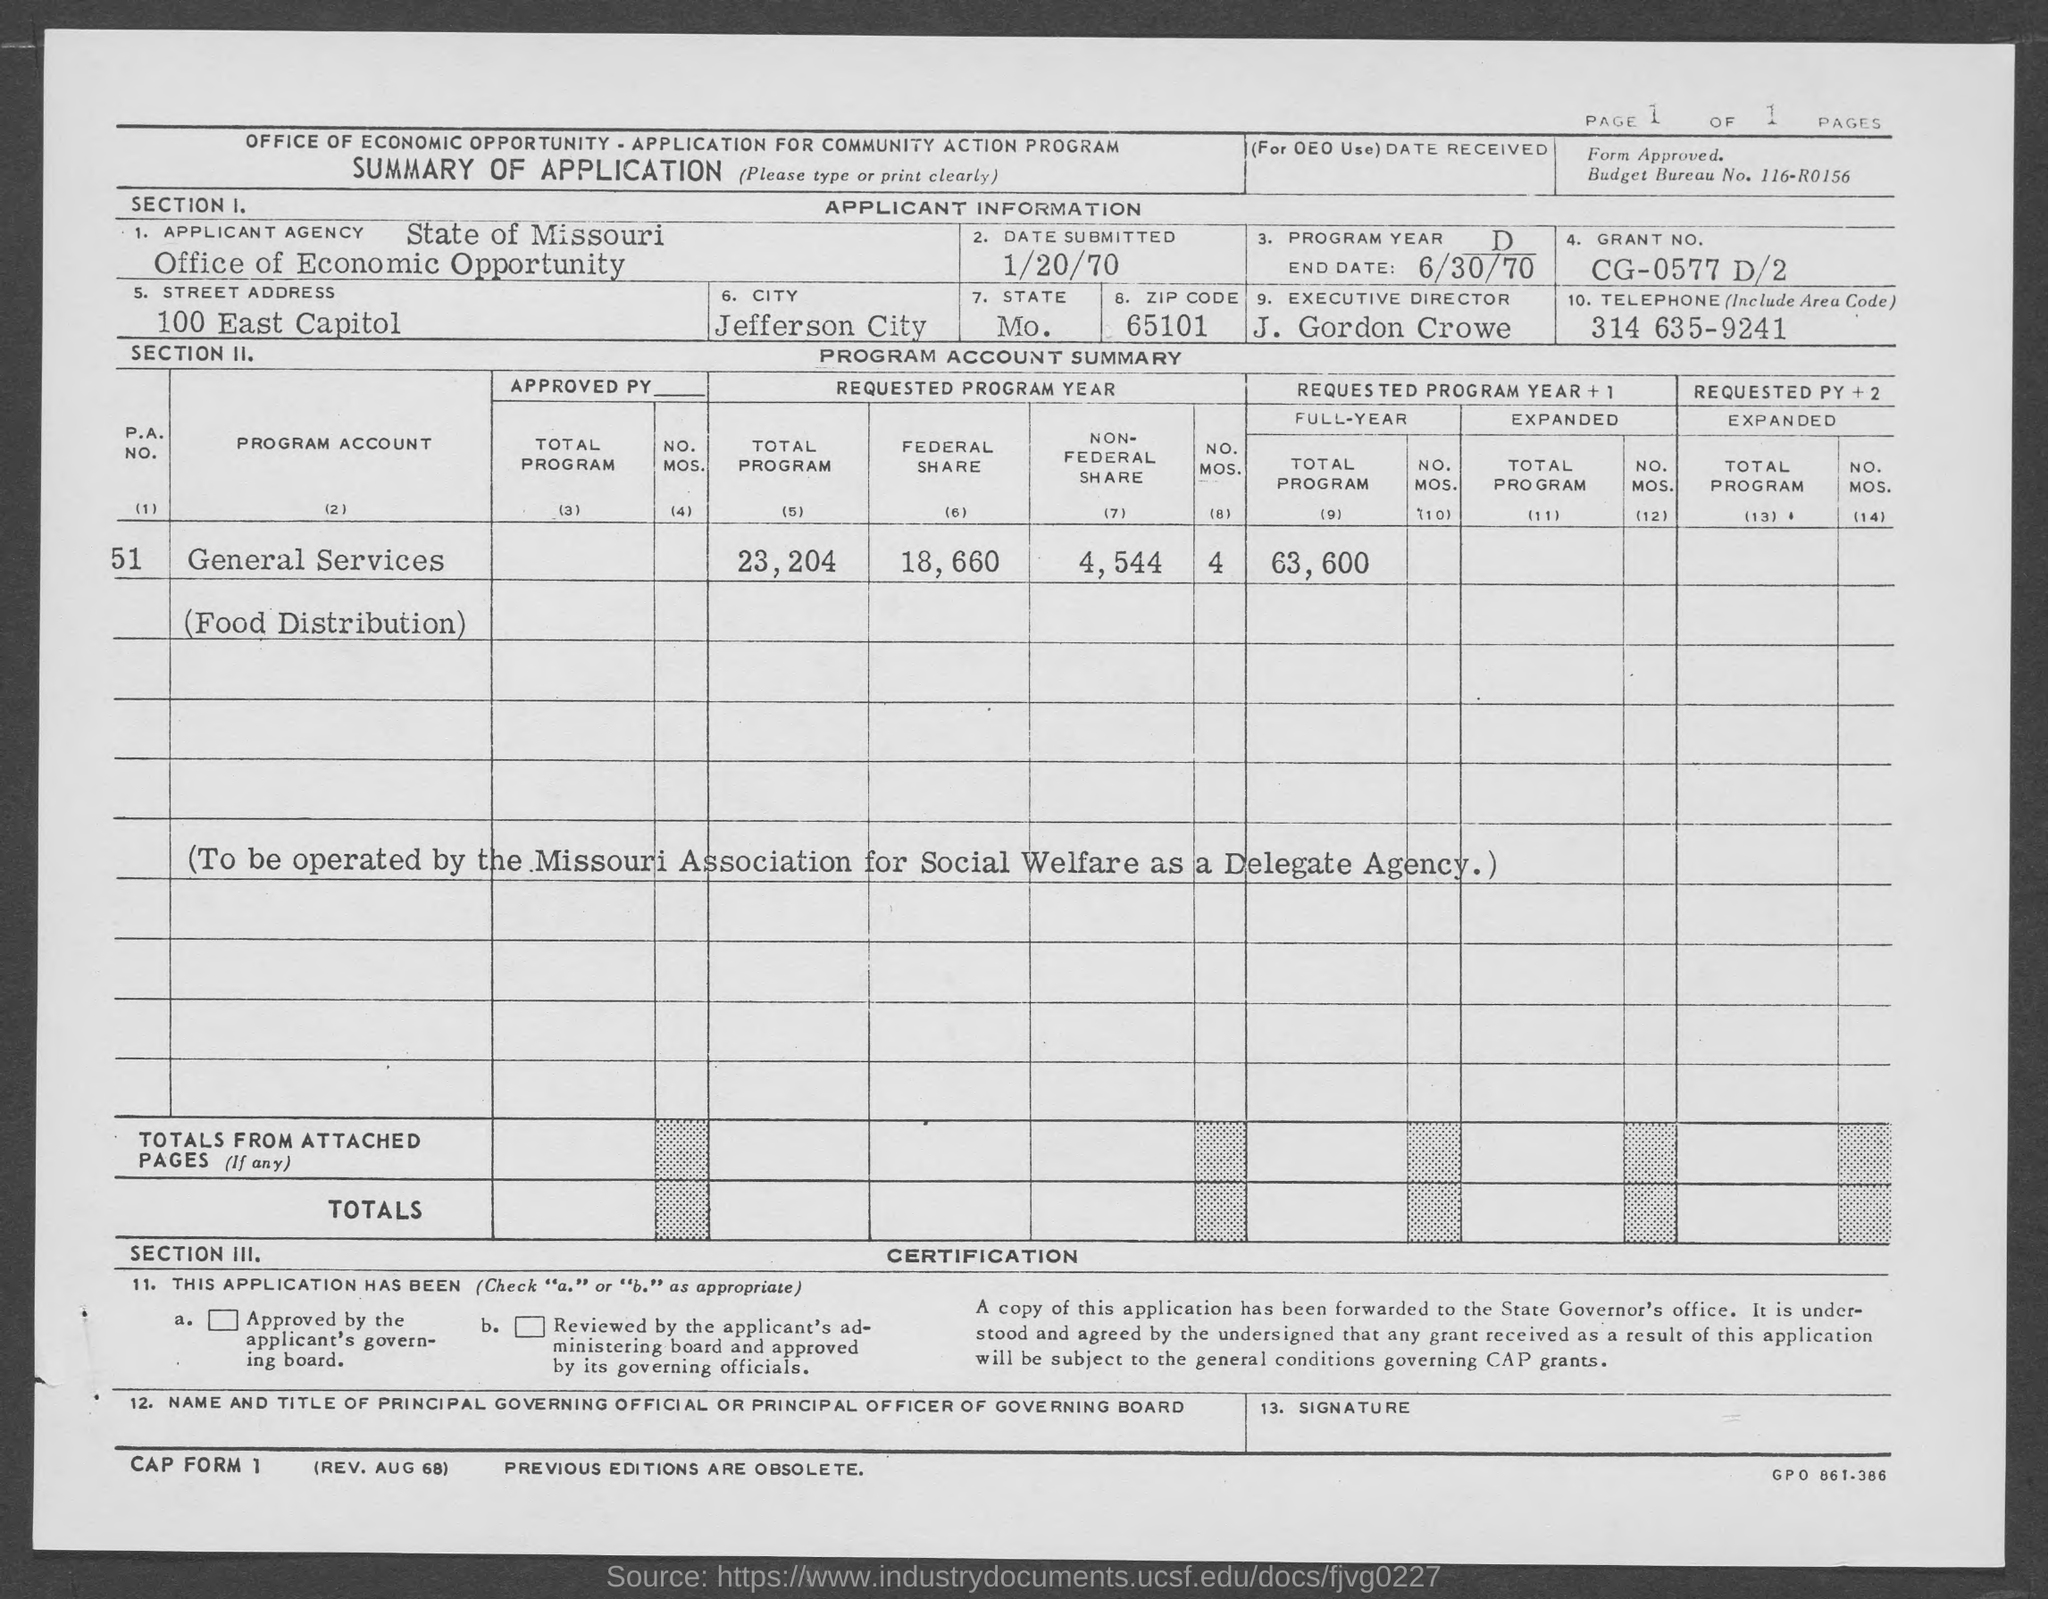List a handful of essential elements in this visual. The city name is JEFFERSON CITY. The Grant No. is CG-0577 D/2. The date of submission is January 20, 1970. The state is a question that has been asked. The street address of the office of Economic Opportunity is located at 100 East Capitol Street. 